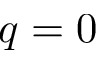<formula> <loc_0><loc_0><loc_500><loc_500>q = 0</formula> 